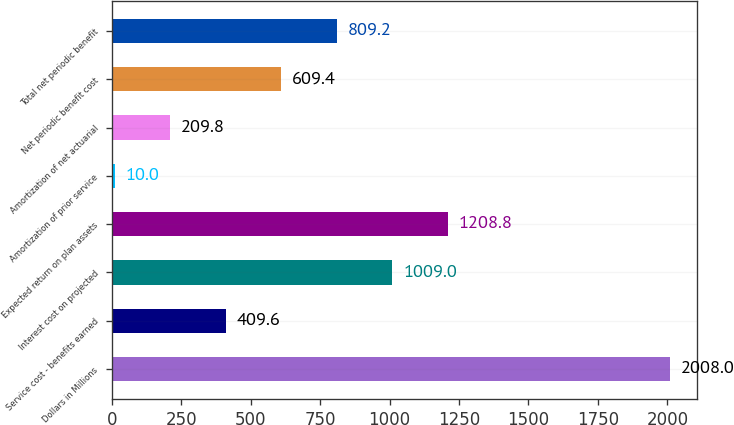Convert chart to OTSL. <chart><loc_0><loc_0><loc_500><loc_500><bar_chart><fcel>Dollars in Millions<fcel>Service cost - benefits earned<fcel>Interest cost on projected<fcel>Expected return on plan assets<fcel>Amortization of prior service<fcel>Amortization of net actuarial<fcel>Net periodic benefit cost<fcel>Total net periodic benefit<nl><fcel>2008<fcel>409.6<fcel>1009<fcel>1208.8<fcel>10<fcel>209.8<fcel>609.4<fcel>809.2<nl></chart> 